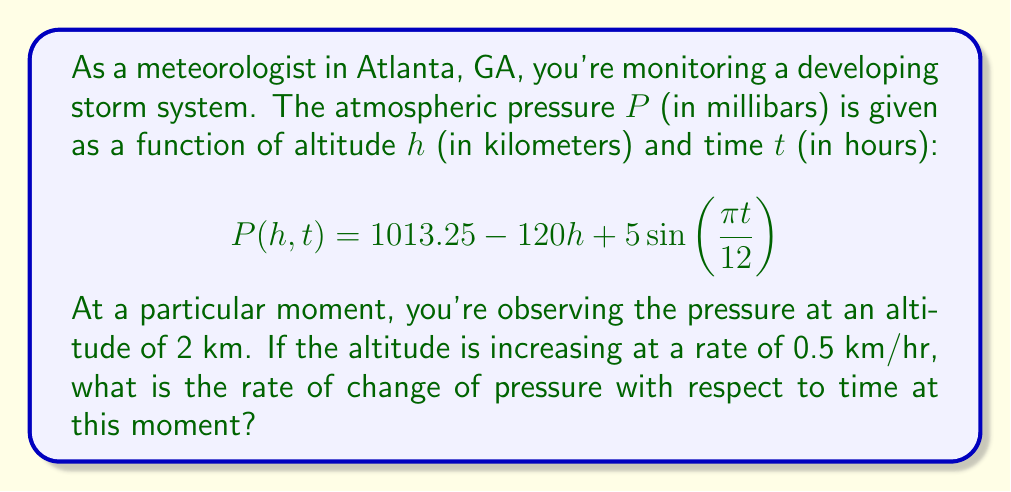Give your solution to this math problem. To solve this problem, we need to use the chain rule for partial derivatives. The rate of change of pressure with respect to time is given by:

$$\frac{dP}{dt} = \frac{\partial P}{\partial t} + \frac{\partial P}{\partial h} \cdot \frac{dh}{dt}$$

Let's break this down step-by-step:

1) First, we need to calculate $\frac{\partial P}{\partial t}$:
   $$\frac{\partial P}{\partial t} = 5 \cdot \frac{\pi}{12} \cos(\frac{\pi t}{12})$$

2) Next, we calculate $\frac{\partial P}{\partial h}$:
   $$\frac{\partial P}{\partial h} = -120$$

3) We're given that $\frac{dh}{dt} = 0.5$ km/hr

4) Now we can substitute these values into our equation:

   $$\frac{dP}{dt} = 5 \cdot \frac{\pi}{12} \cos(\frac{\pi t}{12}) + (-120) \cdot 0.5$$

5) Simplify:
   $$\frac{dP}{dt} = \frac{5\pi}{12} \cos(\frac{\pi t}{12}) - 60$$

This is the general formula for the rate of change of pressure with respect to time. However, the question asks for the rate at a particular moment. Since we're not given a specific time $t$, we can't evaluate the cosine term. Therefore, this is our final answer.
Answer: $$\frac{dP}{dt} = \frac{5\pi}{12} \cos(\frac{\pi t}{12}) - 60$$ mb/hr 